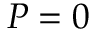Convert formula to latex. <formula><loc_0><loc_0><loc_500><loc_500>P = 0</formula> 